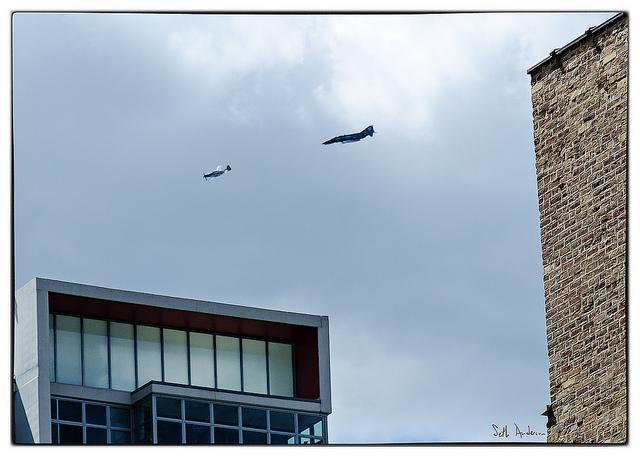Are any of them in use in the photo?
Quick response, please. Yes. What is flying?
Write a very short answer. Plane. Does the window need painting?
Be succinct. No. Is there a building or house shown?
Be succinct. Building. What is in the sky?
Quick response, please. Planes. 